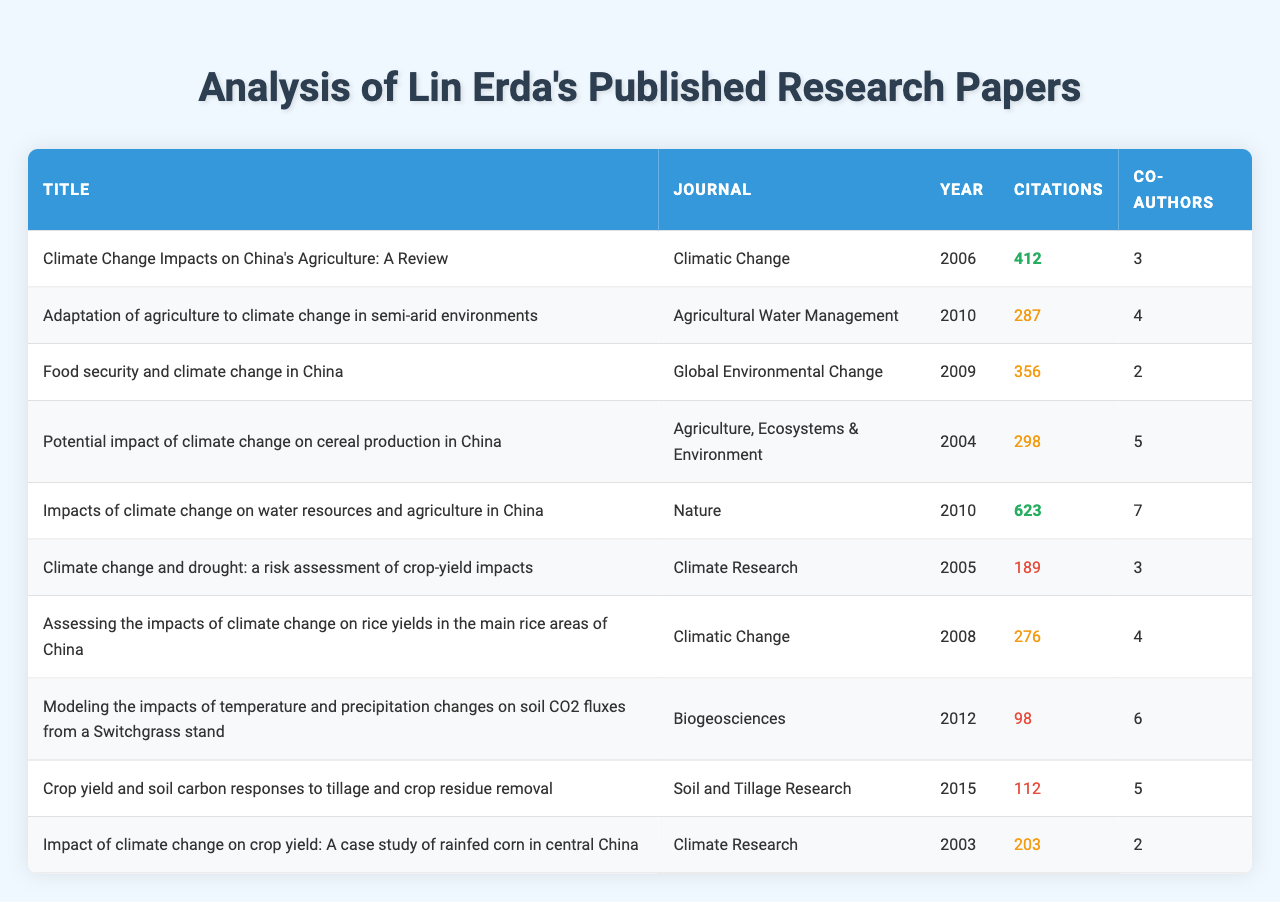What is the title of the paper with the highest number of citations? The paper with the highest number of citations, which can be seen in the "Citations" column, is "Impacts of climate change on water resources and agriculture in China," with 623 citations.
Answer: "Impacts of climate change on water resources and agriculture in China" In which journal was the paper "Adaptation of agriculture to climate change in semi-arid environments" published? By looking at the "Journal" column next to the title, the paper "Adaptation of agriculture to climate change in semi-arid environments" was published in "Agricultural Water Management."
Answer: "Agricultural Water Management" How many co-authors did the paper with the second most citations have? To find the second most citations, first identify the highest citations (623) and then the second highest (412). The paper with 412 citations, which is "Climate Change Impacts on China's Agriculture: A Review," has 3 co-authors.
Answer: 3 What is the average number of citations for all the papers listed? First, calculate the total citations: (412 + 287 + 356 + 298 + 623 + 189 + 276 + 98 + 112 + 203) = 2,967. There are 10 papers in total, so the average is 2967 / 10 = 296.7.
Answer: 296.7 How many papers were published in the journal "Climatic Change"? By scanning the "Journal" column, there are three papers titled "Climate Change Impacts on China's Agriculture: A Review," "Assessing the impacts of climate change on rice yields in the main rice areas of China," and one additional paper published in "Climatic Change."
Answer: 3 Is there a paper published in 2003 that has more than 200 citations? The only paper published in 2003 is "Impact of climate change on crop yield: A case study of rainfed corn in central China," which has 203 citations. Therefore, the statement is true as it has more than 200 citations.
Answer: Yes What is the difference in citations between the highest cited paper and the lowest cited paper? The highest cited paper has 623 citations, while the lowest cited paper, "Modeling the impacts of temperature and precipitation changes on soil CO2 fluxes from a Switchgrass stand," has 98 citations. The difference is calculated as 623 - 98 = 525.
Answer: 525 What percentage of papers have more than 300 citations? There are 10 papers in total. The papers with more than 300 citations are "Climate Change Impacts on China's Agriculture: A Review," "Food security and climate change in China," "Impacts of climate change on water resources and agriculture in China," and "Potential impact of climate change on cereal production in China." This is 4 out of 10 papers, which is 4/10 * 100 = 40%.
Answer: 40% 